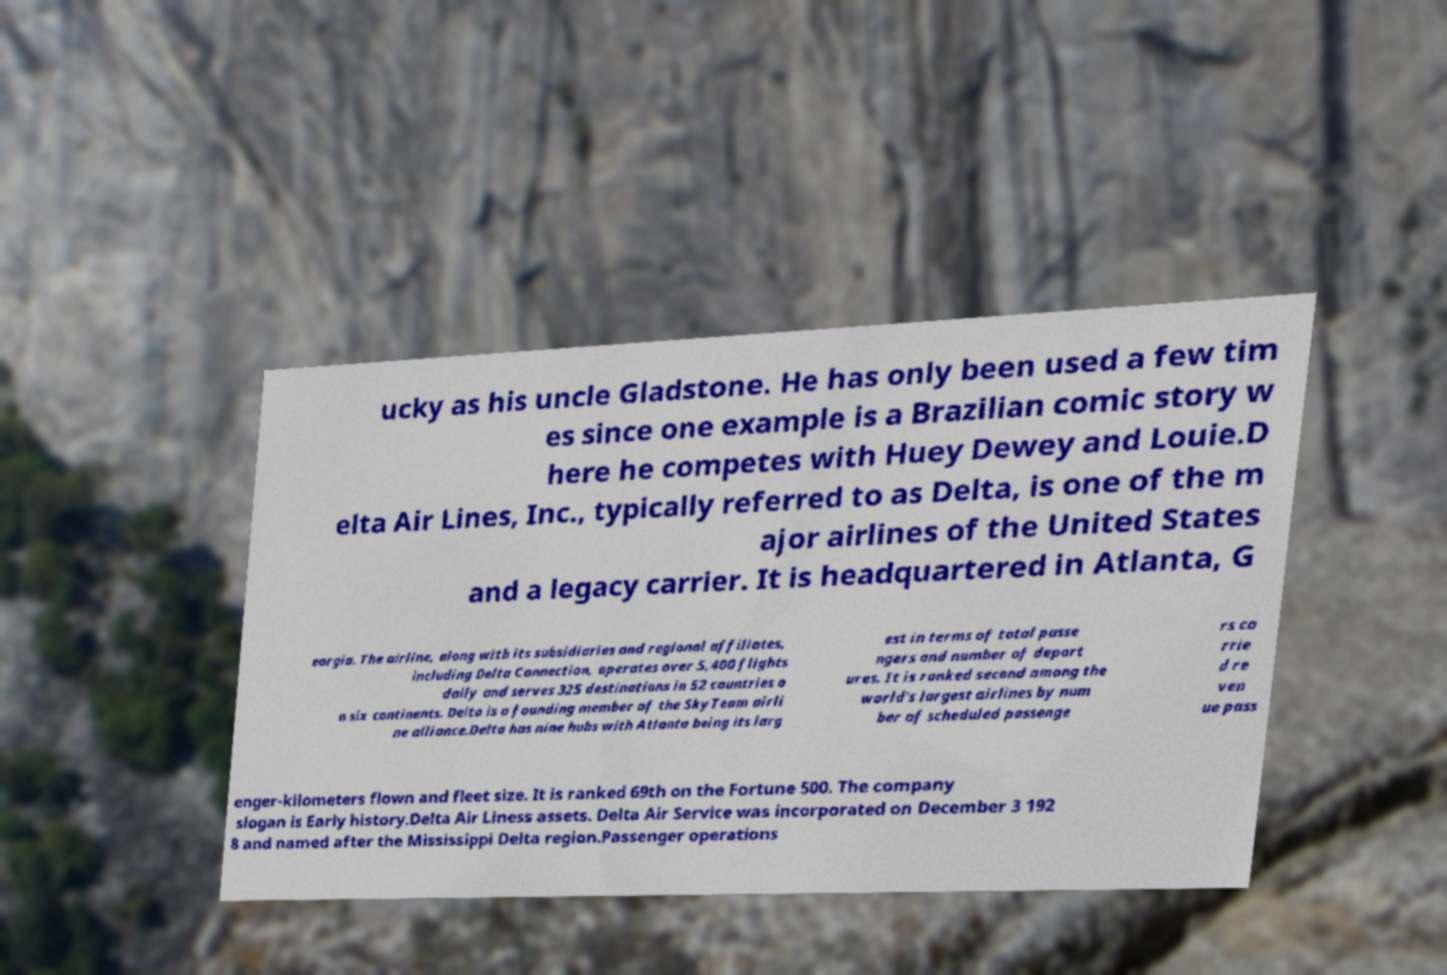Please identify and transcribe the text found in this image. ucky as his uncle Gladstone. He has only been used a few tim es since one example is a Brazilian comic story w here he competes with Huey Dewey and Louie.D elta Air Lines, Inc., typically referred to as Delta, is one of the m ajor airlines of the United States and a legacy carrier. It is headquartered in Atlanta, G eorgia. The airline, along with its subsidiaries and regional affiliates, including Delta Connection, operates over 5,400 flights daily and serves 325 destinations in 52 countries o n six continents. Delta is a founding member of the SkyTeam airli ne alliance.Delta has nine hubs with Atlanta being its larg est in terms of total passe ngers and number of depart ures. It is ranked second among the world's largest airlines by num ber of scheduled passenge rs ca rrie d re ven ue pass enger-kilometers flown and fleet size. It is ranked 69th on the Fortune 500. The company slogan is Early history.Delta Air Liness assets. Delta Air Service was incorporated on December 3 192 8 and named after the Mississippi Delta region.Passenger operations 